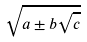Convert formula to latex. <formula><loc_0><loc_0><loc_500><loc_500>\sqrt { a \pm b \sqrt { c } }</formula> 